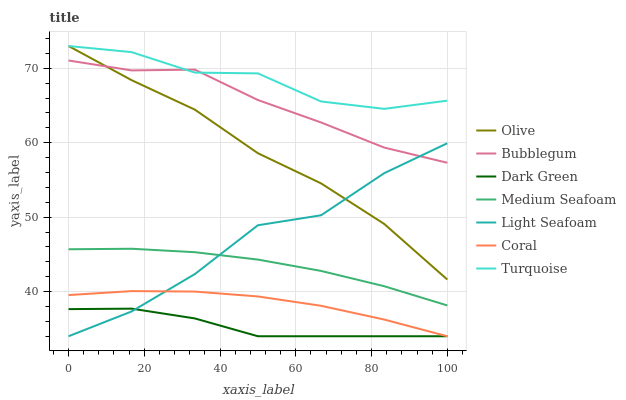Does Dark Green have the minimum area under the curve?
Answer yes or no. Yes. Does Turquoise have the maximum area under the curve?
Answer yes or no. Yes. Does Coral have the minimum area under the curve?
Answer yes or no. No. Does Coral have the maximum area under the curve?
Answer yes or no. No. Is Medium Seafoam the smoothest?
Answer yes or no. Yes. Is Light Seafoam the roughest?
Answer yes or no. Yes. Is Coral the smoothest?
Answer yes or no. No. Is Coral the roughest?
Answer yes or no. No. Does Coral have the lowest value?
Answer yes or no. Yes. Does Bubblegum have the lowest value?
Answer yes or no. No. Does Olive have the highest value?
Answer yes or no. Yes. Does Coral have the highest value?
Answer yes or no. No. Is Coral less than Olive?
Answer yes or no. Yes. Is Olive greater than Dark Green?
Answer yes or no. Yes. Does Olive intersect Turquoise?
Answer yes or no. Yes. Is Olive less than Turquoise?
Answer yes or no. No. Is Olive greater than Turquoise?
Answer yes or no. No. Does Coral intersect Olive?
Answer yes or no. No. 